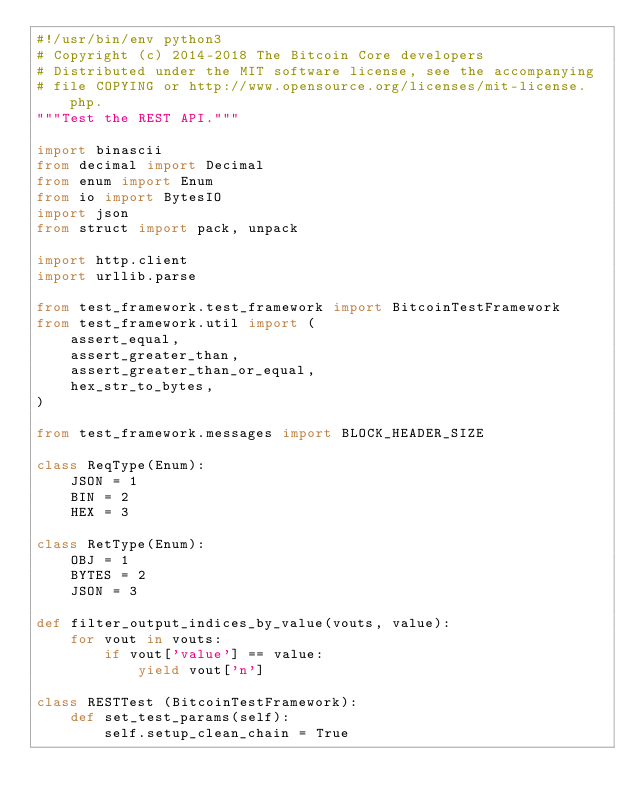<code> <loc_0><loc_0><loc_500><loc_500><_Python_>#!/usr/bin/env python3
# Copyright (c) 2014-2018 The Bitcoin Core developers
# Distributed under the MIT software license, see the accompanying
# file COPYING or http://www.opensource.org/licenses/mit-license.php.
"""Test the REST API."""

import binascii
from decimal import Decimal
from enum import Enum
from io import BytesIO
import json
from struct import pack, unpack

import http.client
import urllib.parse

from test_framework.test_framework import BitcoinTestFramework
from test_framework.util import (
    assert_equal,
    assert_greater_than,
    assert_greater_than_or_equal,
    hex_str_to_bytes,
)

from test_framework.messages import BLOCK_HEADER_SIZE

class ReqType(Enum):
    JSON = 1
    BIN = 2
    HEX = 3

class RetType(Enum):
    OBJ = 1
    BYTES = 2
    JSON = 3

def filter_output_indices_by_value(vouts, value):
    for vout in vouts:
        if vout['value'] == value:
            yield vout['n']

class RESTTest (BitcoinTestFramework):
    def set_test_params(self):
        self.setup_clean_chain = True</code> 